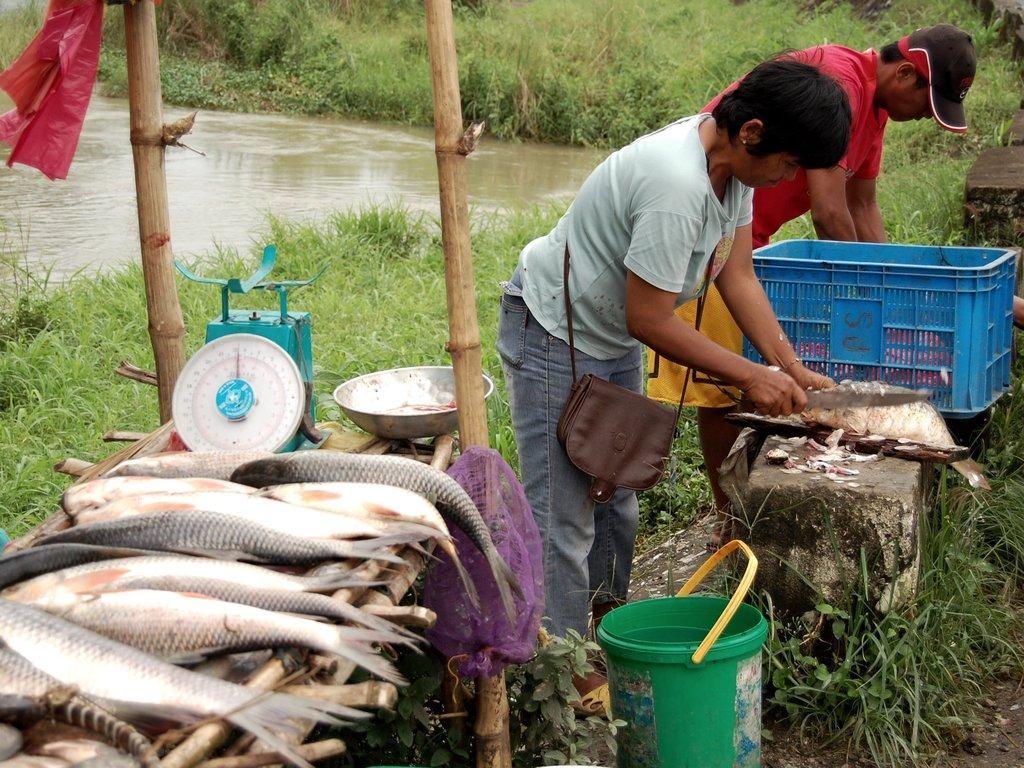Can you describe this image briefly? In this image we can see some fishes which are on bench there is bucket, bowl there are two persons who are cutting fishes which are in blue color bin and in the background of the image there is grass and water. 